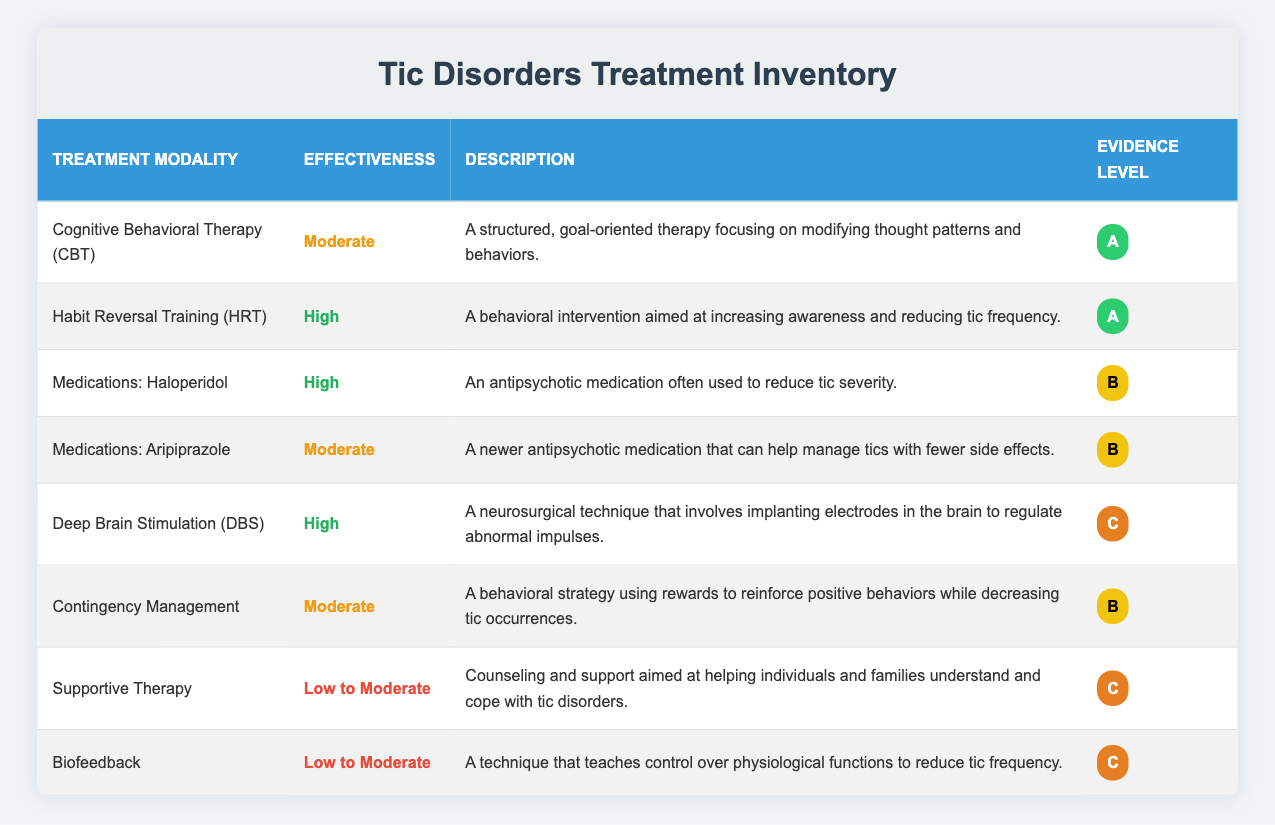What is the effectiveness level of Habit Reversal Training (HRT)? The effectiveness level of Habit Reversal Training (HRT) is stated directly in the table as "High."
Answer: High How many treatment modalities have a high effectiveness rating? The table lists three modalities with a high effectiveness rating: Habit Reversal Training (HRT), Medications: Haloperidol, and Deep Brain Stimulation (DBS). Therefore, the total is 3.
Answer: 3 Is there any treatment modality listed with a low effectiveness rating? Yes, there are two treatment modalities with a low effectiveness rating, which are Supportive Therapy and Biofeedback.
Answer: Yes What is the average effectiveness rating of the treatment modalities based on their classification? We classify ratings as High = 3, Moderate = 2, and Low to Moderate = 1. There are 3 High, 4 Moderate, and 2 Low to Moderate ratings. The average effectiveness calculation is (3*3 + 4*2 + 2*1) / 9 = 2.33, which corresponds to a Moderate effectiveness.
Answer: Moderate What is the description of the treatment modality with the highest evidence level? The highest evidence level is "A," and the modalities with this rating are Cognitive Behavioral Therapy (CBT) and Habit Reversal Training (HRT). Their descriptions are: "A structured, goal-oriented therapy focusing on modifying thought patterns and behaviors" for CBT and "A behavioral intervention aimed at increasing awareness and reducing tic frequency" for HRT. Therefore, both descriptions need to be considered.
Answer: CBT: A structured, goal-oriented therapy focusing on modifying thought patterns and behaviors; HRT: A behavioral intervention aimed at increasing awareness and reducing tic frequency 